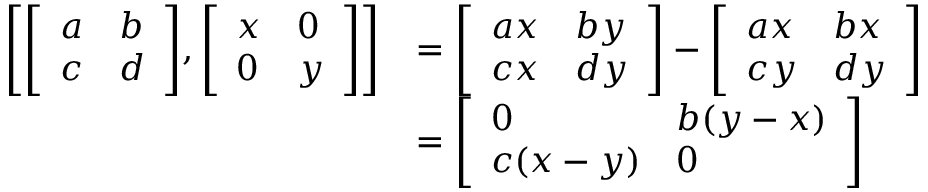<formula> <loc_0><loc_0><loc_500><loc_500>{ \begin{array} { r l } { \left [ { \left [ \begin{array} { l l } { a } & { b } \\ { c } & { d } \end{array} \right ] } , { \left [ \begin{array} { l l } { x } & { 0 } \\ { 0 } & { y } \end{array} \right ] } \right ] } & { = { \left [ \begin{array} { l l } { a x } & { b y } \\ { c x } & { d y } \end{array} \right ] } - { \left [ \begin{array} { l l } { a x } & { b x } \\ { c y } & { d y } \end{array} \right ] } } \\ & { = { \left [ \begin{array} { l l } { 0 } & { b ( y - x ) } \\ { c ( x - y ) } & { 0 } \end{array} \right ] } } \end{array} }</formula> 